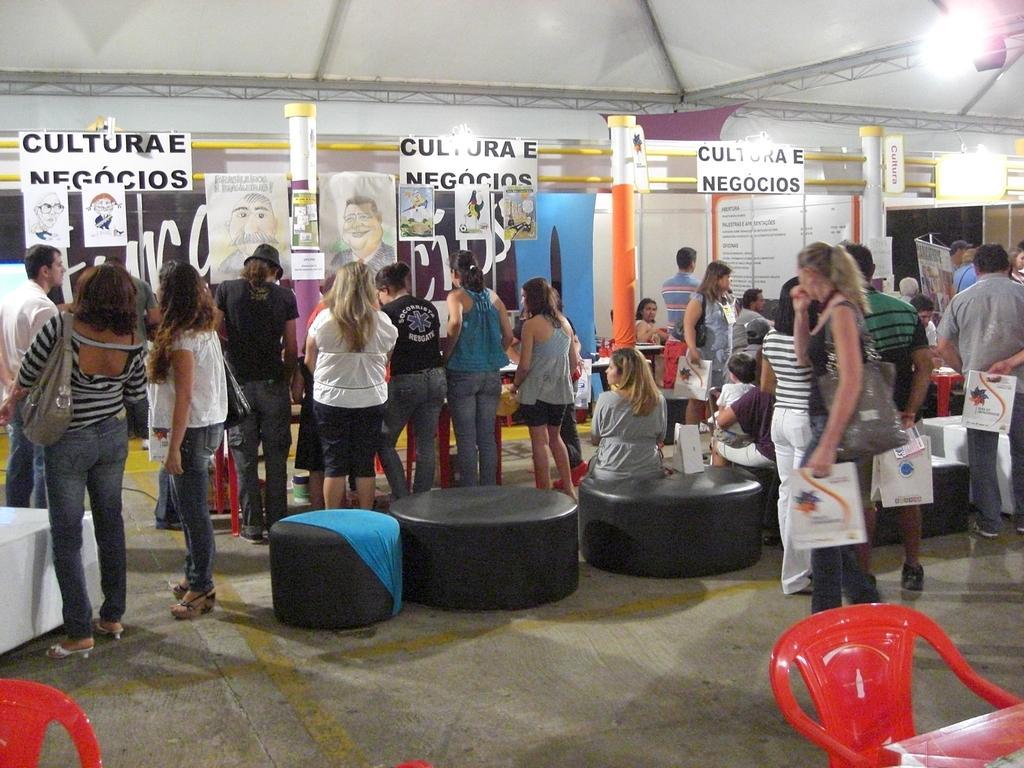In one or two sentences, can you explain what this image depicts? In this picture we can see chairs, stools and a group of people standing on the floor and some objects and in the background we can see posts, name boards, pillars, lights. 